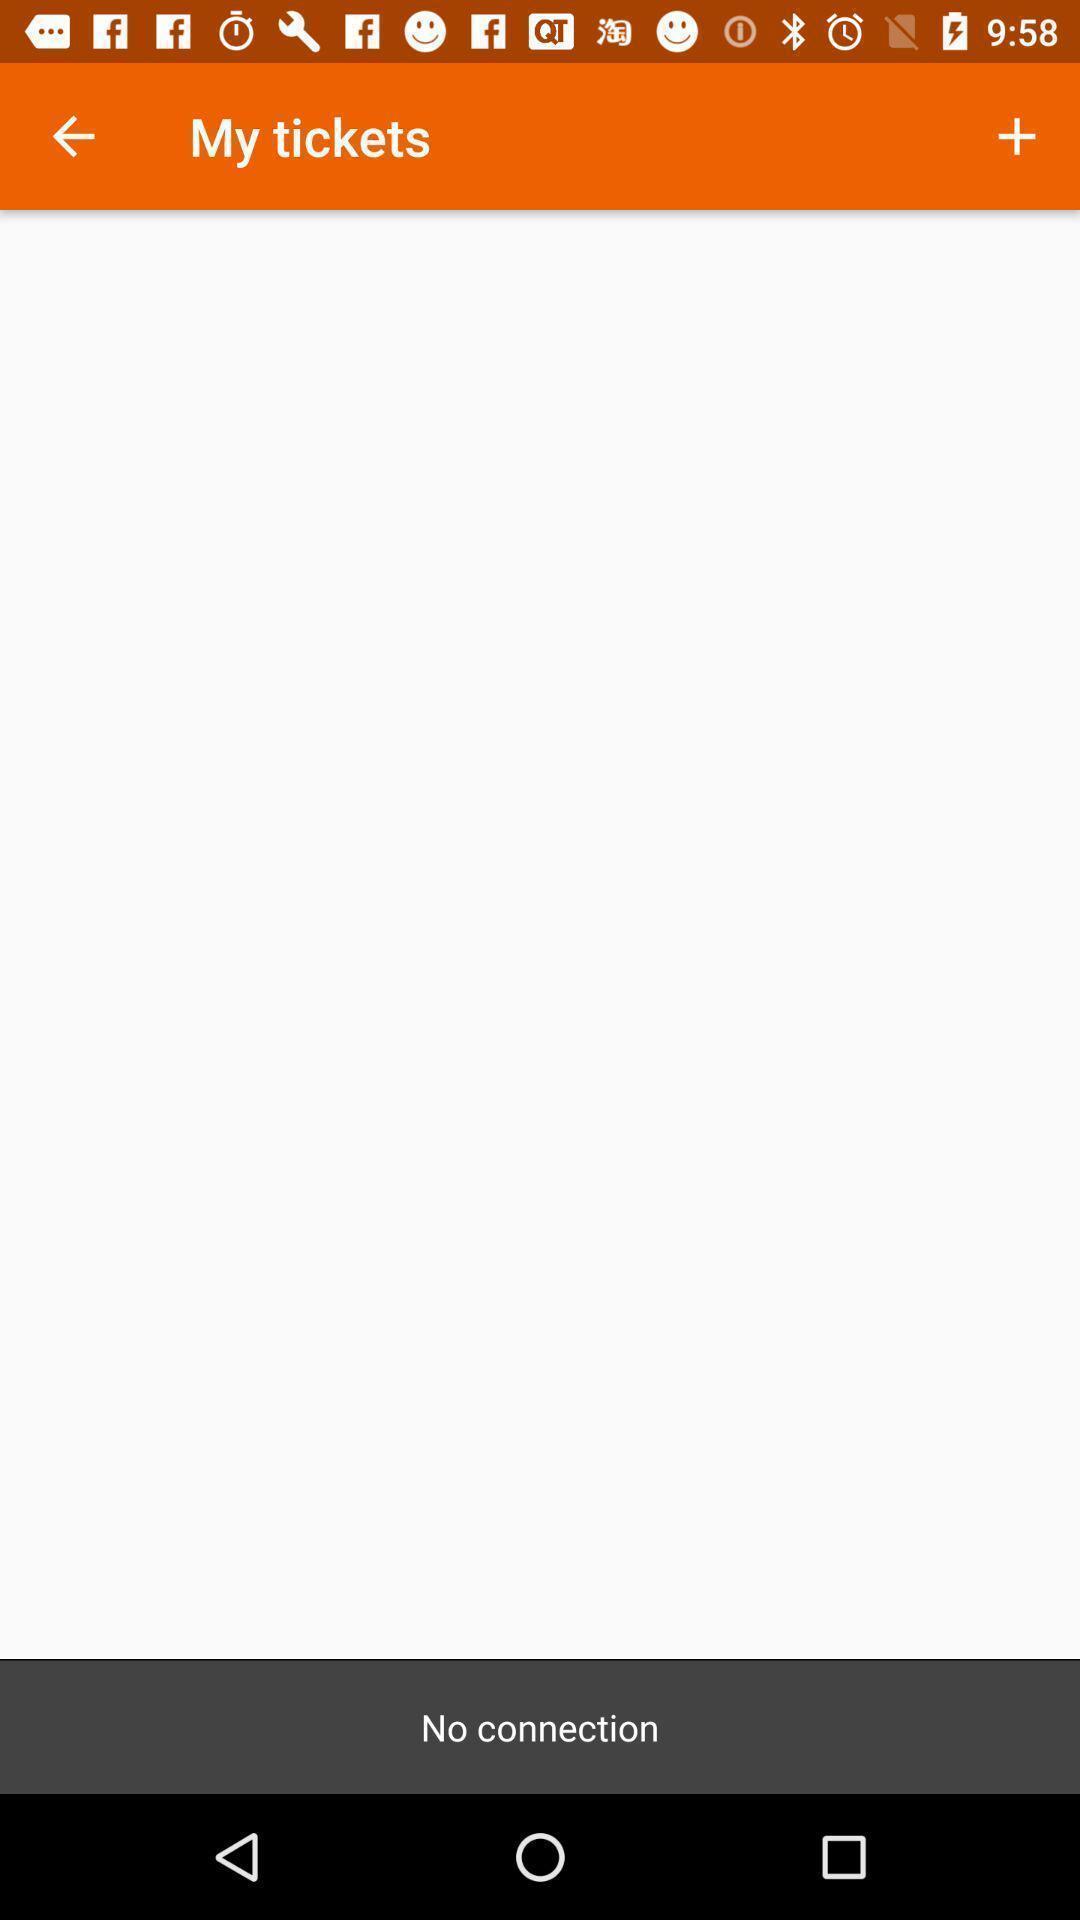What can you discern from this picture? Screen displaying the my tickets page. 